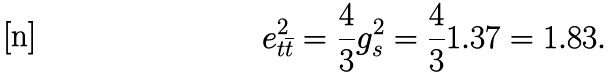<formula> <loc_0><loc_0><loc_500><loc_500>e _ { t \overline { t } } ^ { 2 } = \frac { 4 } { 3 } g _ { s } ^ { 2 } = \frac { 4 } { 3 } 1 . 3 7 = 1 . 8 3 .</formula> 